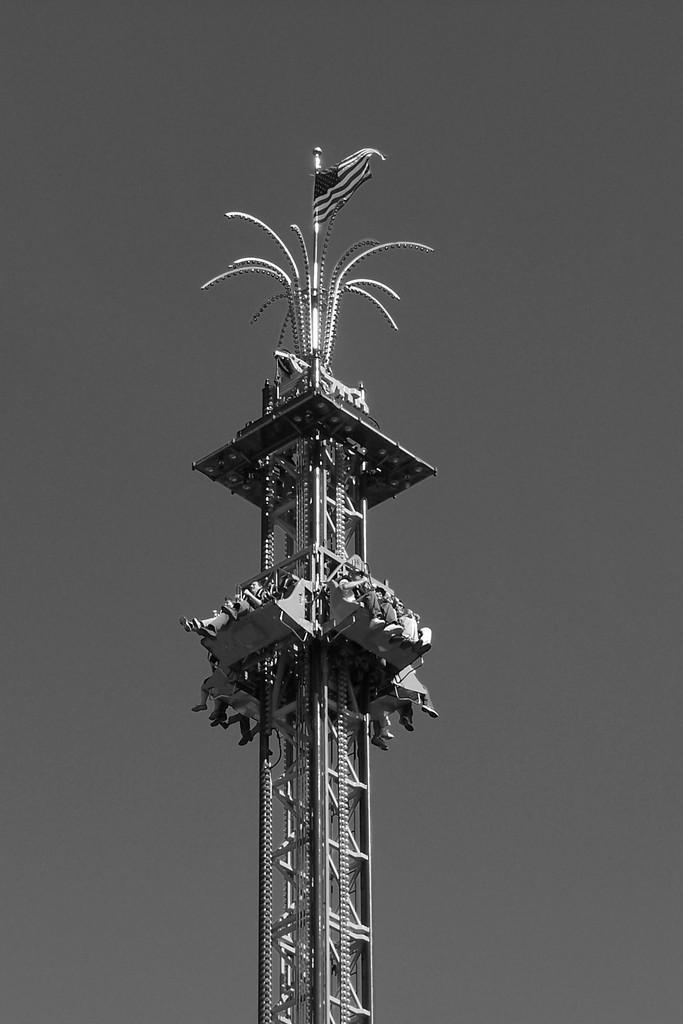Describe this image in one or two sentences. In this black and white image we can see many people are sitting on the drop tower and at the top we can see a flag. 